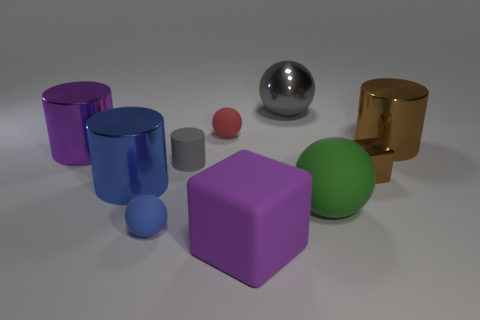Is there any other thing that has the same color as the big matte sphere?
Your answer should be compact. No. There is a cylinder right of the metallic sphere; is it the same size as the rubber block?
Provide a short and direct response. Yes. There is a metal cylinder that is on the right side of the gray metal sphere; how many metal things are left of it?
Offer a terse response. 4. Is there a metallic thing that is right of the big green matte sphere behind the small ball on the left side of the small gray thing?
Offer a very short reply. Yes. What material is the purple thing that is the same shape as the big blue metallic thing?
Your answer should be very brief. Metal. Does the small red thing have the same material as the large object that is in front of the small blue matte sphere?
Make the answer very short. Yes. There is a tiny object in front of the cube that is behind the blue cylinder; what is its shape?
Your answer should be compact. Sphere. What number of small objects are purple cylinders or yellow objects?
Offer a very short reply. 0. What number of tiny gray rubber things have the same shape as the blue rubber object?
Offer a terse response. 0. There is a large purple metal object; is it the same shape as the big rubber thing on the right side of the gray metallic object?
Offer a very short reply. No. 